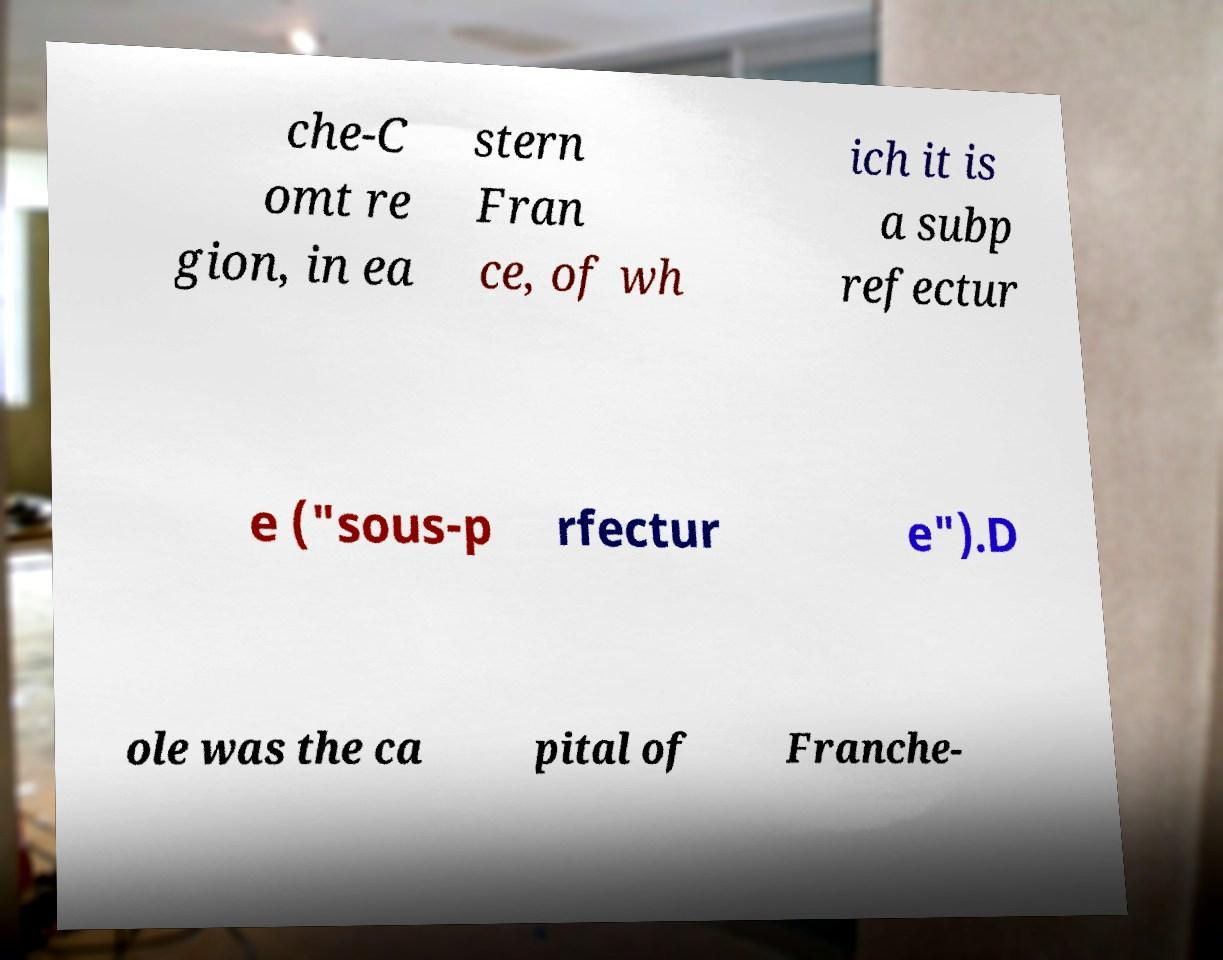Could you assist in decoding the text presented in this image and type it out clearly? che-C omt re gion, in ea stern Fran ce, of wh ich it is a subp refectur e ("sous-p rfectur e").D ole was the ca pital of Franche- 